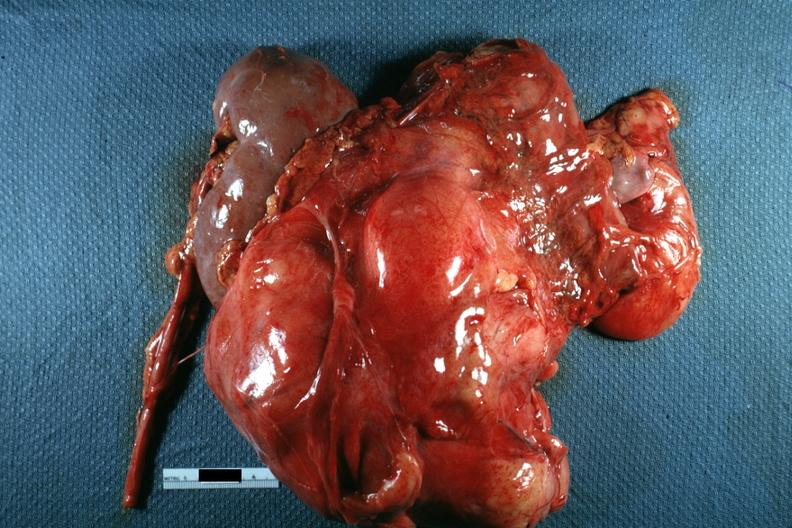how is nodular mass with kidney seen on one side photo of use without showing cut surface?
Answer the question using a single word or phrase. Little 